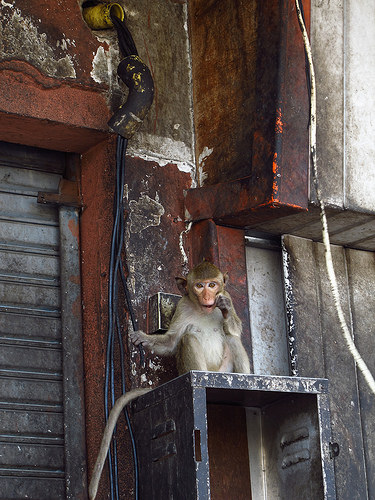<image>
Is there a shutter on the monkey? No. The shutter is not positioned on the monkey. They may be near each other, but the shutter is not supported by or resting on top of the monkey. 